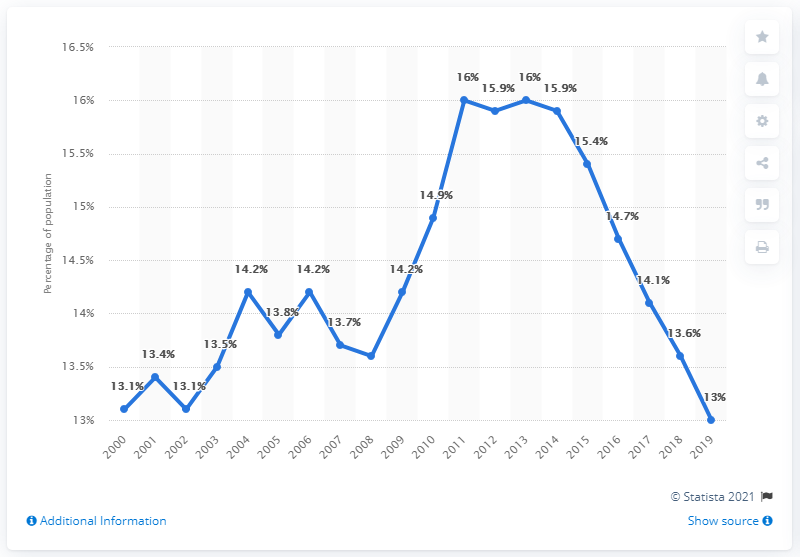List a handful of essential elements in this visual. The difference between the highest point and the lowest point is 3. The value of the highest point is 16. 